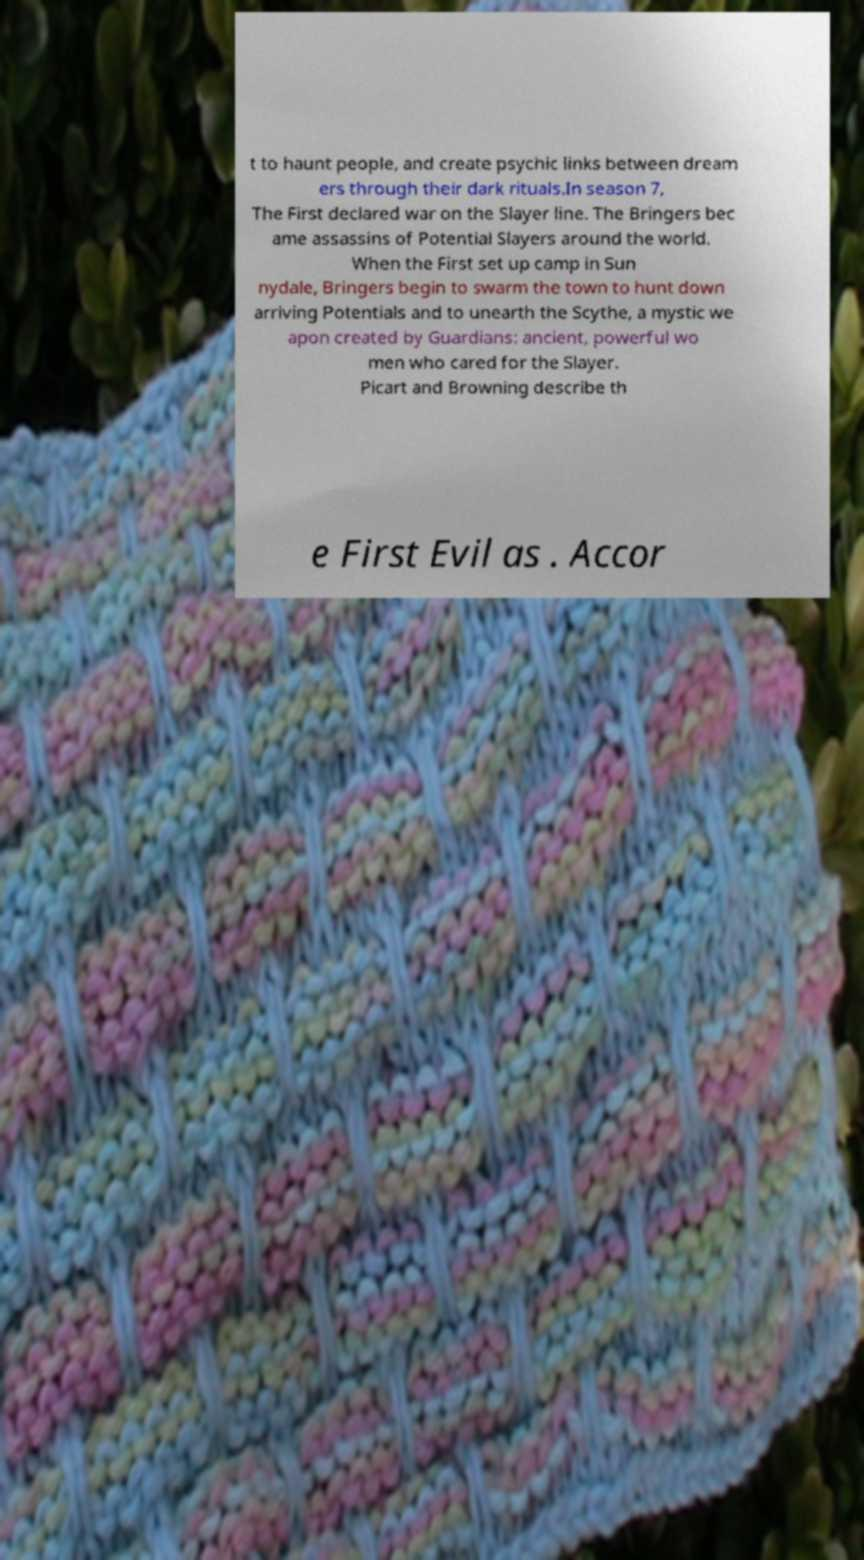Can you accurately transcribe the text from the provided image for me? t to haunt people, and create psychic links between dream ers through their dark rituals.In season 7, The First declared war on the Slayer line. The Bringers bec ame assassins of Potential Slayers around the world. When the First set up camp in Sun nydale, Bringers begin to swarm the town to hunt down arriving Potentials and to unearth the Scythe, a mystic we apon created by Guardians: ancient, powerful wo men who cared for the Slayer. Picart and Browning describe th e First Evil as . Accor 